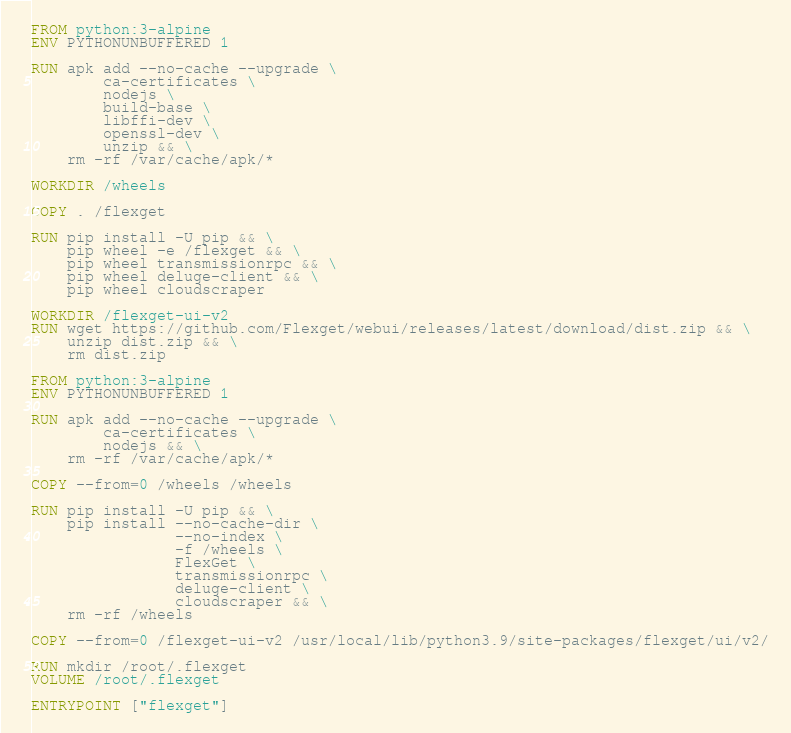<code> <loc_0><loc_0><loc_500><loc_500><_Dockerfile_>FROM python:3-alpine
ENV PYTHONUNBUFFERED 1

RUN apk add --no-cache --upgrade \
        ca-certificates \
        nodejs \
        build-base \
        libffi-dev \
        openssl-dev \
        unzip && \
    rm -rf /var/cache/apk/*

WORKDIR /wheels

COPY . /flexget

RUN pip install -U pip && \
    pip wheel -e /flexget && \
    pip wheel transmissionrpc && \
    pip wheel deluge-client && \
    pip wheel cloudscraper

WORKDIR /flexget-ui-v2
RUN wget https://github.com/Flexget/webui/releases/latest/download/dist.zip && \
    unzip dist.zip && \
    rm dist.zip

FROM python:3-alpine
ENV PYTHONUNBUFFERED 1

RUN apk add --no-cache --upgrade \
        ca-certificates \
        nodejs && \
    rm -rf /var/cache/apk/*

COPY --from=0 /wheels /wheels

RUN pip install -U pip && \
    pip install --no-cache-dir \
                --no-index \
                -f /wheels \
                FlexGet \
                transmissionrpc \
                deluge-client \
                cloudscraper && \
    rm -rf /wheels

COPY --from=0 /flexget-ui-v2 /usr/local/lib/python3.9/site-packages/flexget/ui/v2/

RUN mkdir /root/.flexget
VOLUME /root/.flexget

ENTRYPOINT ["flexget"]
</code> 